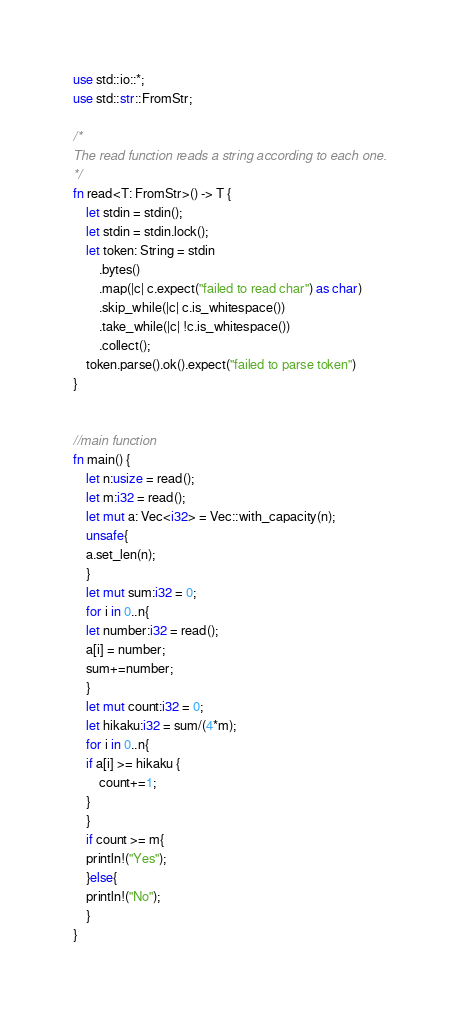Convert code to text. <code><loc_0><loc_0><loc_500><loc_500><_Rust_>use std::io::*;
use std::str::FromStr;
 
/* 
The read function reads a string according to each one. 
*/
fn read<T: FromStr>() -> T {
    let stdin = stdin();
    let stdin = stdin.lock();
    let token: String = stdin
        .bytes()
        .map(|c| c.expect("failed to read char") as char) 
        .skip_while(|c| c.is_whitespace())
        .take_while(|c| !c.is_whitespace())
        .collect();
    token.parse().ok().expect("failed to parse token")
}
 
 
//main function
fn main() {
    let n:usize = read();
    let m:i32 = read();
    let mut a: Vec<i32> = Vec::with_capacity(n);
    unsafe{
	a.set_len(n);
    }
    let mut sum:i32 = 0;
    for i in 0..n{
	let number:i32 = read();
	a[i] = number;
	sum+=number;
    }
    let mut count:i32 = 0;
    let hikaku:i32 = sum/(4*m);
    for i in 0..n{
	if a[i] >= hikaku {
	    count+=1;
	}
    }
    if count >= m{
	println!("Yes");
    }else{
	println!("No");
    }
}
</code> 